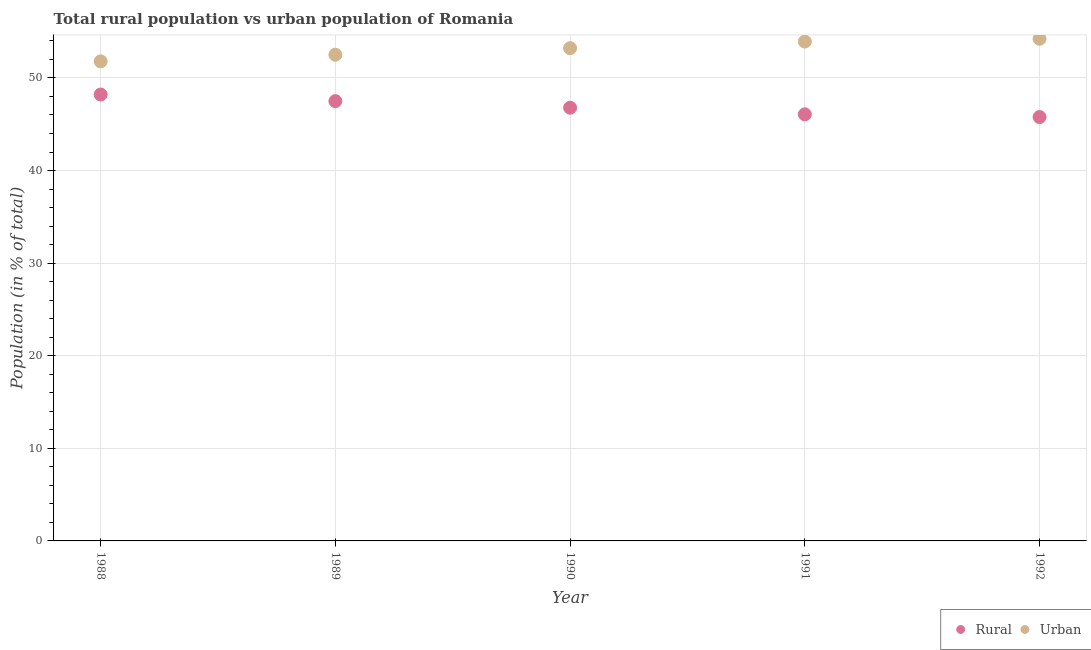Is the number of dotlines equal to the number of legend labels?
Your answer should be very brief. Yes. What is the urban population in 1991?
Give a very brief answer. 53.93. Across all years, what is the maximum urban population?
Your answer should be very brief. 54.23. Across all years, what is the minimum rural population?
Your answer should be very brief. 45.77. In which year was the urban population maximum?
Provide a succinct answer. 1992. What is the total rural population in the graph?
Your answer should be very brief. 234.33. What is the difference between the urban population in 1989 and that in 1990?
Your answer should be very brief. -0.71. What is the difference between the urban population in 1989 and the rural population in 1990?
Give a very brief answer. 5.72. What is the average rural population per year?
Provide a succinct answer. 46.87. In the year 1991, what is the difference between the urban population and rural population?
Offer a terse response. 7.86. In how many years, is the urban population greater than 24 %?
Offer a terse response. 5. What is the ratio of the urban population in 1989 to that in 1992?
Your answer should be very brief. 0.97. What is the difference between the highest and the second highest rural population?
Make the answer very short. 0.71. What is the difference between the highest and the lowest rural population?
Provide a short and direct response. 2.44. In how many years, is the rural population greater than the average rural population taken over all years?
Give a very brief answer. 2. Is the urban population strictly less than the rural population over the years?
Your response must be concise. No. How many years are there in the graph?
Your answer should be compact. 5. What is the difference between two consecutive major ticks on the Y-axis?
Provide a succinct answer. 10. Are the values on the major ticks of Y-axis written in scientific E-notation?
Your answer should be very brief. No. Does the graph contain any zero values?
Make the answer very short. No. Does the graph contain grids?
Your response must be concise. Yes. Where does the legend appear in the graph?
Provide a short and direct response. Bottom right. How are the legend labels stacked?
Offer a very short reply. Horizontal. What is the title of the graph?
Provide a short and direct response. Total rural population vs urban population of Romania. What is the label or title of the Y-axis?
Give a very brief answer. Population (in % of total). What is the Population (in % of total) of Rural in 1988?
Your response must be concise. 48.21. What is the Population (in % of total) of Urban in 1988?
Your answer should be compact. 51.79. What is the Population (in % of total) in Rural in 1989?
Make the answer very short. 47.5. What is the Population (in % of total) in Urban in 1989?
Make the answer very short. 52.5. What is the Population (in % of total) in Rural in 1990?
Your response must be concise. 46.78. What is the Population (in % of total) of Urban in 1990?
Offer a very short reply. 53.22. What is the Population (in % of total) in Rural in 1991?
Keep it short and to the point. 46.07. What is the Population (in % of total) in Urban in 1991?
Your answer should be compact. 53.93. What is the Population (in % of total) of Rural in 1992?
Provide a short and direct response. 45.77. What is the Population (in % of total) in Urban in 1992?
Provide a short and direct response. 54.23. Across all years, what is the maximum Population (in % of total) of Rural?
Ensure brevity in your answer.  48.21. Across all years, what is the maximum Population (in % of total) of Urban?
Ensure brevity in your answer.  54.23. Across all years, what is the minimum Population (in % of total) in Rural?
Make the answer very short. 45.77. Across all years, what is the minimum Population (in % of total) of Urban?
Your answer should be very brief. 51.79. What is the total Population (in % of total) of Rural in the graph?
Offer a terse response. 234.33. What is the total Population (in % of total) of Urban in the graph?
Your answer should be very brief. 265.67. What is the difference between the Population (in % of total) of Rural in 1988 and that in 1989?
Your response must be concise. 0.71. What is the difference between the Population (in % of total) in Urban in 1988 and that in 1989?
Offer a very short reply. -0.71. What is the difference between the Population (in % of total) of Rural in 1988 and that in 1990?
Ensure brevity in your answer.  1.43. What is the difference between the Population (in % of total) in Urban in 1988 and that in 1990?
Give a very brief answer. -1.43. What is the difference between the Population (in % of total) in Rural in 1988 and that in 1991?
Keep it short and to the point. 2.14. What is the difference between the Population (in % of total) of Urban in 1988 and that in 1991?
Your answer should be compact. -2.14. What is the difference between the Population (in % of total) in Rural in 1988 and that in 1992?
Make the answer very short. 2.44. What is the difference between the Population (in % of total) in Urban in 1988 and that in 1992?
Your answer should be very brief. -2.44. What is the difference between the Population (in % of total) of Rural in 1989 and that in 1990?
Give a very brief answer. 0.71. What is the difference between the Population (in % of total) of Urban in 1989 and that in 1990?
Ensure brevity in your answer.  -0.71. What is the difference between the Population (in % of total) in Rural in 1989 and that in 1991?
Your answer should be very brief. 1.43. What is the difference between the Population (in % of total) in Urban in 1989 and that in 1991?
Ensure brevity in your answer.  -1.43. What is the difference between the Population (in % of total) in Rural in 1989 and that in 1992?
Give a very brief answer. 1.72. What is the difference between the Population (in % of total) of Urban in 1989 and that in 1992?
Offer a very short reply. -1.72. What is the difference between the Population (in % of total) in Rural in 1990 and that in 1991?
Ensure brevity in your answer.  0.71. What is the difference between the Population (in % of total) of Urban in 1990 and that in 1991?
Keep it short and to the point. -0.71. What is the difference between the Population (in % of total) of Rural in 1990 and that in 1992?
Offer a terse response. 1.01. What is the difference between the Population (in % of total) of Urban in 1990 and that in 1992?
Provide a short and direct response. -1.01. What is the difference between the Population (in % of total) of Rural in 1991 and that in 1992?
Make the answer very short. 0.3. What is the difference between the Population (in % of total) in Urban in 1991 and that in 1992?
Provide a short and direct response. -0.3. What is the difference between the Population (in % of total) of Rural in 1988 and the Population (in % of total) of Urban in 1989?
Offer a very short reply. -4.29. What is the difference between the Population (in % of total) in Rural in 1988 and the Population (in % of total) in Urban in 1990?
Keep it short and to the point. -5.01. What is the difference between the Population (in % of total) of Rural in 1988 and the Population (in % of total) of Urban in 1991?
Give a very brief answer. -5.72. What is the difference between the Population (in % of total) of Rural in 1988 and the Population (in % of total) of Urban in 1992?
Give a very brief answer. -6.02. What is the difference between the Population (in % of total) of Rural in 1989 and the Population (in % of total) of Urban in 1990?
Offer a very short reply. -5.72. What is the difference between the Population (in % of total) of Rural in 1989 and the Population (in % of total) of Urban in 1991?
Your response must be concise. -6.43. What is the difference between the Population (in % of total) of Rural in 1989 and the Population (in % of total) of Urban in 1992?
Your response must be concise. -6.73. What is the difference between the Population (in % of total) in Rural in 1990 and the Population (in % of total) in Urban in 1991?
Provide a succinct answer. -7.15. What is the difference between the Population (in % of total) of Rural in 1990 and the Population (in % of total) of Urban in 1992?
Offer a terse response. -7.44. What is the difference between the Population (in % of total) of Rural in 1991 and the Population (in % of total) of Urban in 1992?
Offer a very short reply. -8.16. What is the average Population (in % of total) of Rural per year?
Give a very brief answer. 46.87. What is the average Population (in % of total) in Urban per year?
Give a very brief answer. 53.13. In the year 1988, what is the difference between the Population (in % of total) of Rural and Population (in % of total) of Urban?
Offer a very short reply. -3.58. In the year 1989, what is the difference between the Population (in % of total) in Rural and Population (in % of total) in Urban?
Your response must be concise. -5.01. In the year 1990, what is the difference between the Population (in % of total) of Rural and Population (in % of total) of Urban?
Offer a very short reply. -6.43. In the year 1991, what is the difference between the Population (in % of total) in Rural and Population (in % of total) in Urban?
Provide a succinct answer. -7.86. In the year 1992, what is the difference between the Population (in % of total) in Rural and Population (in % of total) in Urban?
Make the answer very short. -8.45. What is the ratio of the Population (in % of total) of Rural in 1988 to that in 1989?
Ensure brevity in your answer.  1.01. What is the ratio of the Population (in % of total) of Urban in 1988 to that in 1989?
Offer a very short reply. 0.99. What is the ratio of the Population (in % of total) of Rural in 1988 to that in 1990?
Keep it short and to the point. 1.03. What is the ratio of the Population (in % of total) in Urban in 1988 to that in 1990?
Make the answer very short. 0.97. What is the ratio of the Population (in % of total) of Rural in 1988 to that in 1991?
Keep it short and to the point. 1.05. What is the ratio of the Population (in % of total) of Urban in 1988 to that in 1991?
Offer a terse response. 0.96. What is the ratio of the Population (in % of total) of Rural in 1988 to that in 1992?
Give a very brief answer. 1.05. What is the ratio of the Population (in % of total) of Urban in 1988 to that in 1992?
Your answer should be very brief. 0.96. What is the ratio of the Population (in % of total) in Rural in 1989 to that in 1990?
Your response must be concise. 1.02. What is the ratio of the Population (in % of total) in Urban in 1989 to that in 1990?
Provide a short and direct response. 0.99. What is the ratio of the Population (in % of total) of Rural in 1989 to that in 1991?
Provide a short and direct response. 1.03. What is the ratio of the Population (in % of total) of Urban in 1989 to that in 1991?
Provide a succinct answer. 0.97. What is the ratio of the Population (in % of total) of Rural in 1989 to that in 1992?
Your response must be concise. 1.04. What is the ratio of the Population (in % of total) in Urban in 1989 to that in 1992?
Provide a succinct answer. 0.97. What is the ratio of the Population (in % of total) of Rural in 1990 to that in 1991?
Your answer should be compact. 1.02. What is the ratio of the Population (in % of total) of Rural in 1990 to that in 1992?
Give a very brief answer. 1.02. What is the ratio of the Population (in % of total) in Urban in 1990 to that in 1992?
Your response must be concise. 0.98. What is the ratio of the Population (in % of total) of Rural in 1991 to that in 1992?
Keep it short and to the point. 1.01. What is the ratio of the Population (in % of total) of Urban in 1991 to that in 1992?
Provide a short and direct response. 0.99. What is the difference between the highest and the second highest Population (in % of total) of Rural?
Give a very brief answer. 0.71. What is the difference between the highest and the second highest Population (in % of total) in Urban?
Your answer should be compact. 0.3. What is the difference between the highest and the lowest Population (in % of total) in Rural?
Keep it short and to the point. 2.44. What is the difference between the highest and the lowest Population (in % of total) in Urban?
Offer a very short reply. 2.44. 